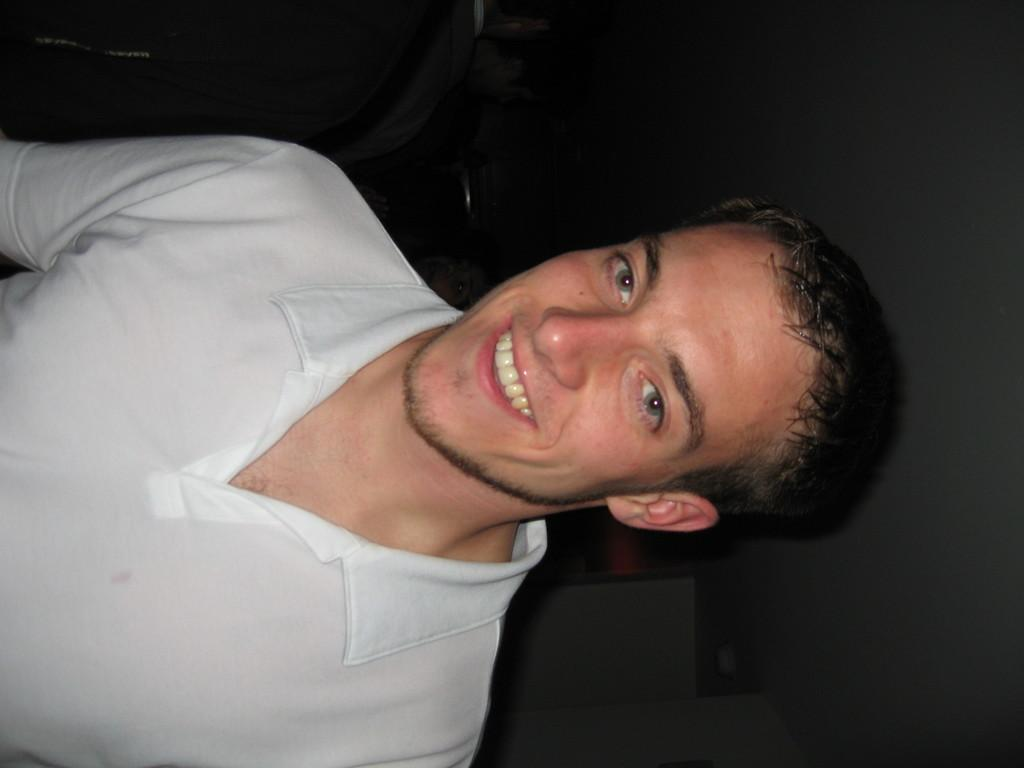What is the person in the image wearing? The person in the image is wearing a white dress. What is the facial expression of the person in the image? The person is smiling. Can you describe the background of the image? The background of the image includes other persons, a ceiling, a wall, and other objects. What type of behavior does the father exhibit in the image? There is no father present in the image, so it is not possible to determine their behavior. 